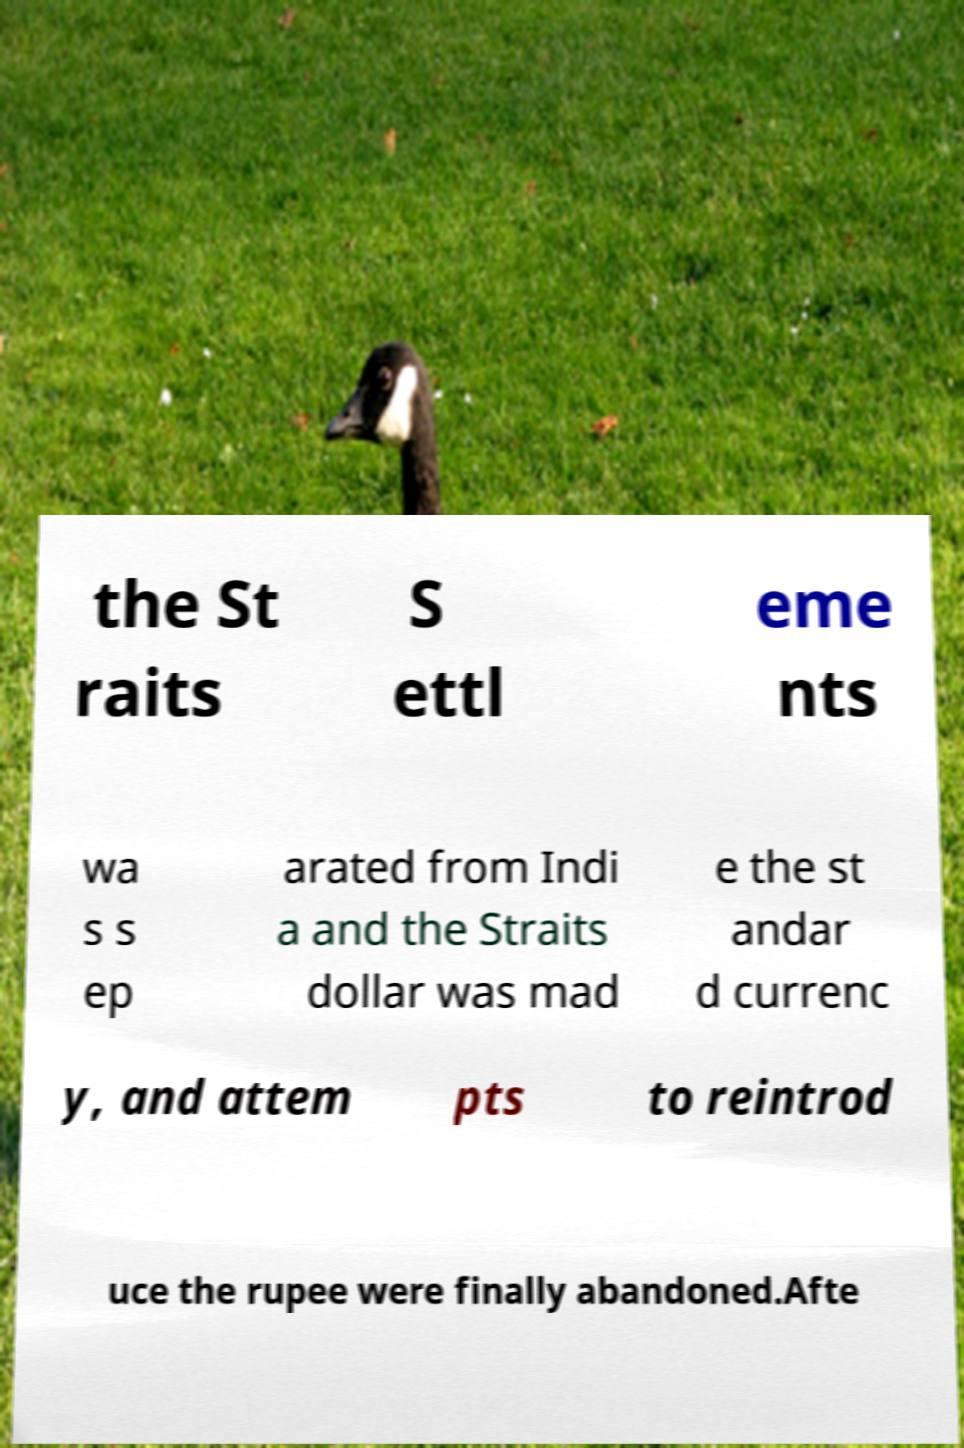Could you assist in decoding the text presented in this image and type it out clearly? the St raits S ettl eme nts wa s s ep arated from Indi a and the Straits dollar was mad e the st andar d currenc y, and attem pts to reintrod uce the rupee were finally abandoned.Afte 